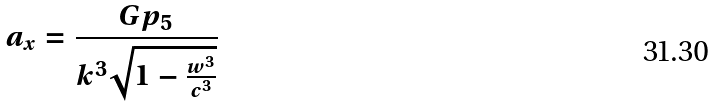Convert formula to latex. <formula><loc_0><loc_0><loc_500><loc_500>a _ { x } = \frac { G p _ { 5 } } { k ^ { 3 } \sqrt { 1 - \frac { w ^ { 3 } } { c ^ { 3 } } } }</formula> 